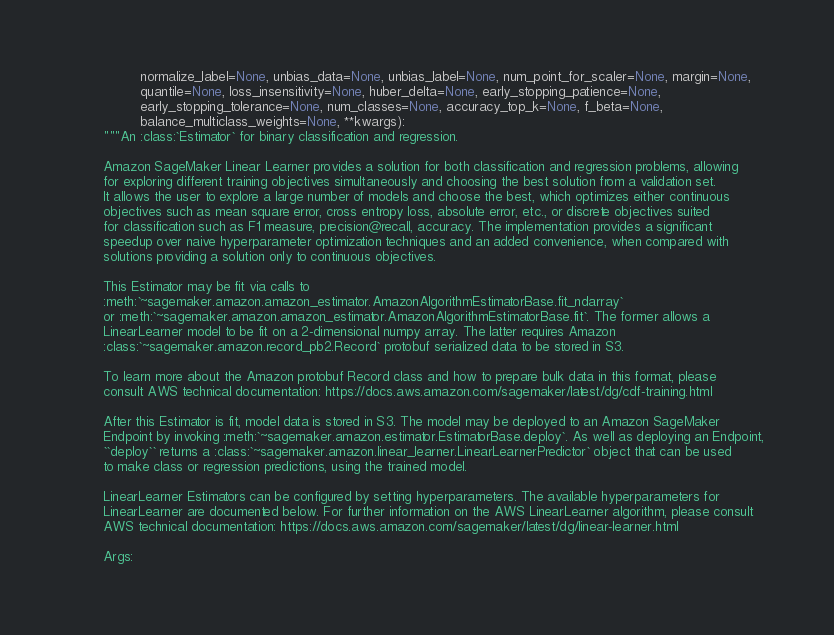Convert code to text. <code><loc_0><loc_0><loc_500><loc_500><_Python_>                 normalize_label=None, unbias_data=None, unbias_label=None, num_point_for_scaler=None, margin=None,
                 quantile=None, loss_insensitivity=None, huber_delta=None, early_stopping_patience=None,
                 early_stopping_tolerance=None, num_classes=None, accuracy_top_k=None, f_beta=None,
                 balance_multiclass_weights=None, **kwargs):
        """An :class:`Estimator` for binary classification and regression.

        Amazon SageMaker Linear Learner provides a solution for both classification and regression problems, allowing
        for exploring different training objectives simultaneously and choosing the best solution from a validation set.
        It allows the user to explore a large number of models and choose the best, which optimizes either continuous
        objectives such as mean square error, cross entropy loss, absolute error, etc., or discrete objectives suited
        for classification such as F1 measure, precision@recall, accuracy. The implementation provides a significant
        speedup over naive hyperparameter optimization techniques and an added convenience, when compared with
        solutions providing a solution only to continuous objectives.

        This Estimator may be fit via calls to
        :meth:`~sagemaker.amazon.amazon_estimator.AmazonAlgorithmEstimatorBase.fit_ndarray`
        or :meth:`~sagemaker.amazon.amazon_estimator.AmazonAlgorithmEstimatorBase.fit`. The former allows a
        LinearLearner model to be fit on a 2-dimensional numpy array. The latter requires Amazon
        :class:`~sagemaker.amazon.record_pb2.Record` protobuf serialized data to be stored in S3.

        To learn more about the Amazon protobuf Record class and how to prepare bulk data in this format, please
        consult AWS technical documentation: https://docs.aws.amazon.com/sagemaker/latest/dg/cdf-training.html

        After this Estimator is fit, model data is stored in S3. The model may be deployed to an Amazon SageMaker
        Endpoint by invoking :meth:`~sagemaker.amazon.estimator.EstimatorBase.deploy`. As well as deploying an Endpoint,
        ``deploy`` returns a :class:`~sagemaker.amazon.linear_learner.LinearLearnerPredictor` object that can be used
        to make class or regression predictions, using the trained model.

        LinearLearner Estimators can be configured by setting hyperparameters. The available hyperparameters for
        LinearLearner are documented below. For further information on the AWS LinearLearner algorithm, please consult
        AWS technical documentation: https://docs.aws.amazon.com/sagemaker/latest/dg/linear-learner.html

        Args:</code> 